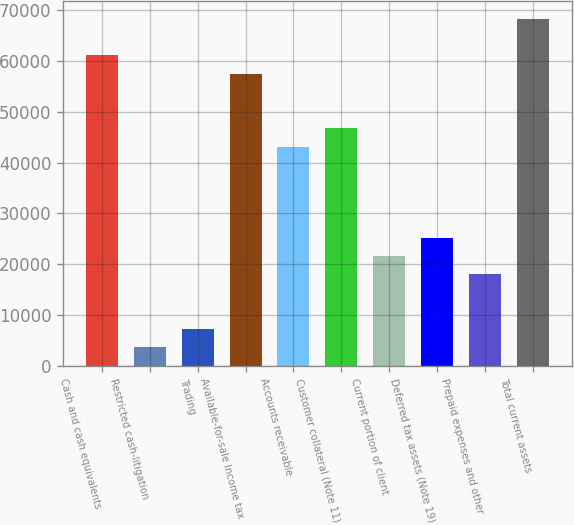<chart> <loc_0><loc_0><loc_500><loc_500><bar_chart><fcel>Cash and cash equivalents<fcel>Restricted cash-litigation<fcel>Trading<fcel>Available-for-sale Income tax<fcel>Accounts receivable<fcel>Customer collateral (Note 11)<fcel>Current portion of client<fcel>Deferred tax assets (Note 19)<fcel>Prepaid expenses and other<fcel>Total current assets<nl><fcel>61121.7<fcel>3600.1<fcel>7195.2<fcel>57526.6<fcel>43146.2<fcel>46741.3<fcel>21575.6<fcel>25170.7<fcel>17980.5<fcel>68311.9<nl></chart> 